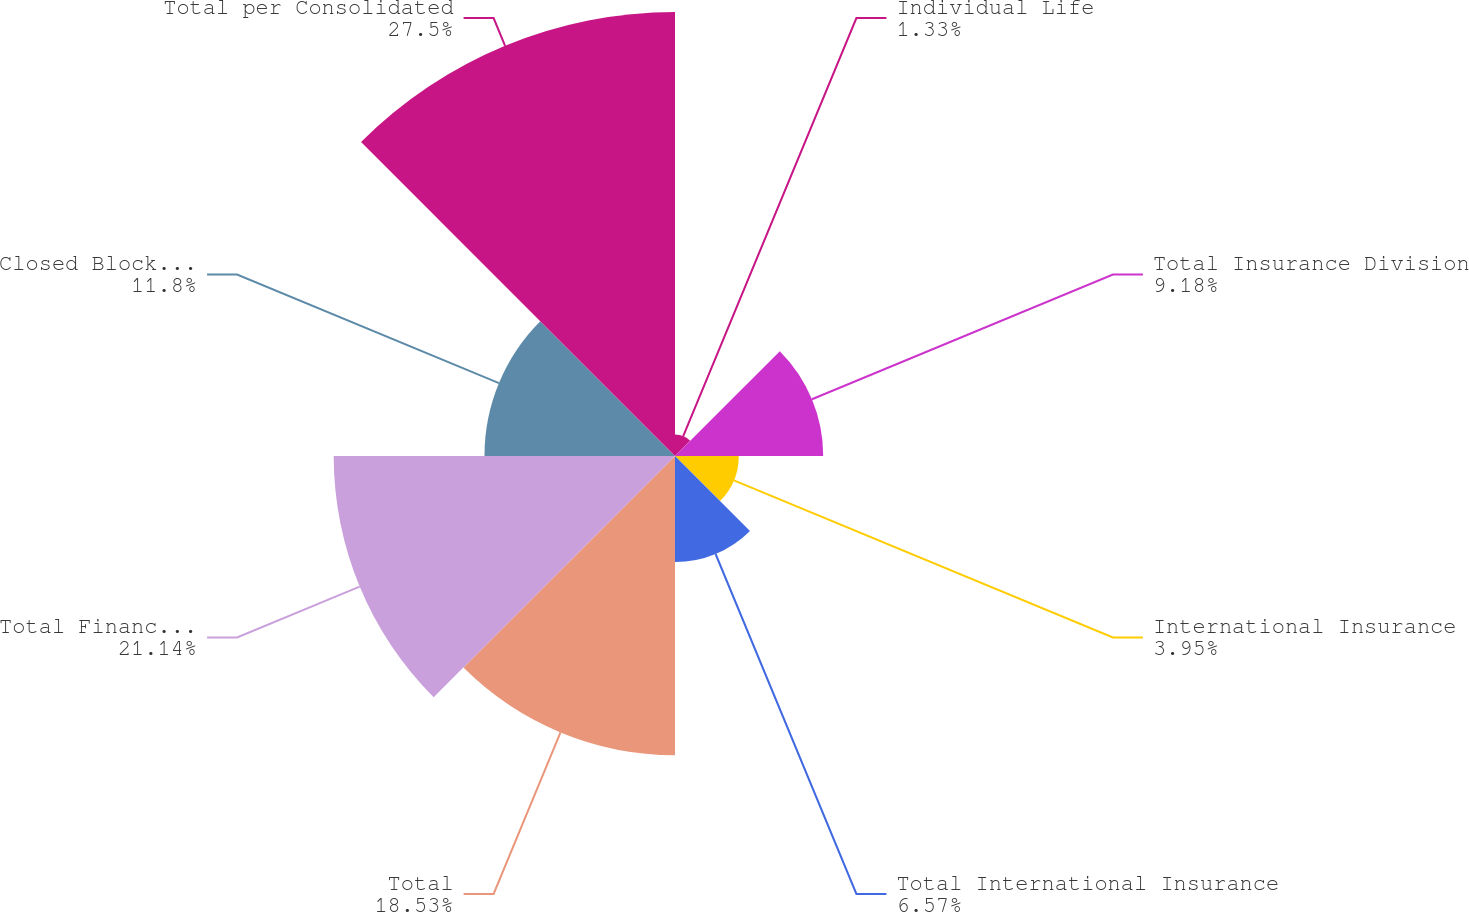Convert chart. <chart><loc_0><loc_0><loc_500><loc_500><pie_chart><fcel>Individual Life<fcel>Total Insurance Division<fcel>International Insurance<fcel>Total International Insurance<fcel>Total<fcel>Total Financial Services<fcel>Closed Block Business<fcel>Total per Consolidated<nl><fcel>1.33%<fcel>9.18%<fcel>3.95%<fcel>6.57%<fcel>18.53%<fcel>21.14%<fcel>11.8%<fcel>27.5%<nl></chart> 